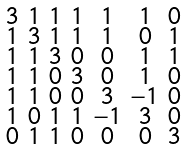Convert formula to latex. <formula><loc_0><loc_0><loc_500><loc_500>\begin{smallmatrix} 3 & 1 & 1 & 1 & 1 & 1 & 0 \\ 1 & 3 & 1 & 1 & 1 & 0 & 1 \\ 1 & 1 & 3 & 0 & 0 & 1 & 1 \\ 1 & 1 & 0 & 3 & 0 & 1 & 0 \\ 1 & 1 & 0 & 0 & 3 & - 1 & 0 \\ 1 & 0 & 1 & 1 & - 1 & 3 & 0 \\ 0 & 1 & 1 & 0 & 0 & 0 & 3 \end{smallmatrix}</formula> 